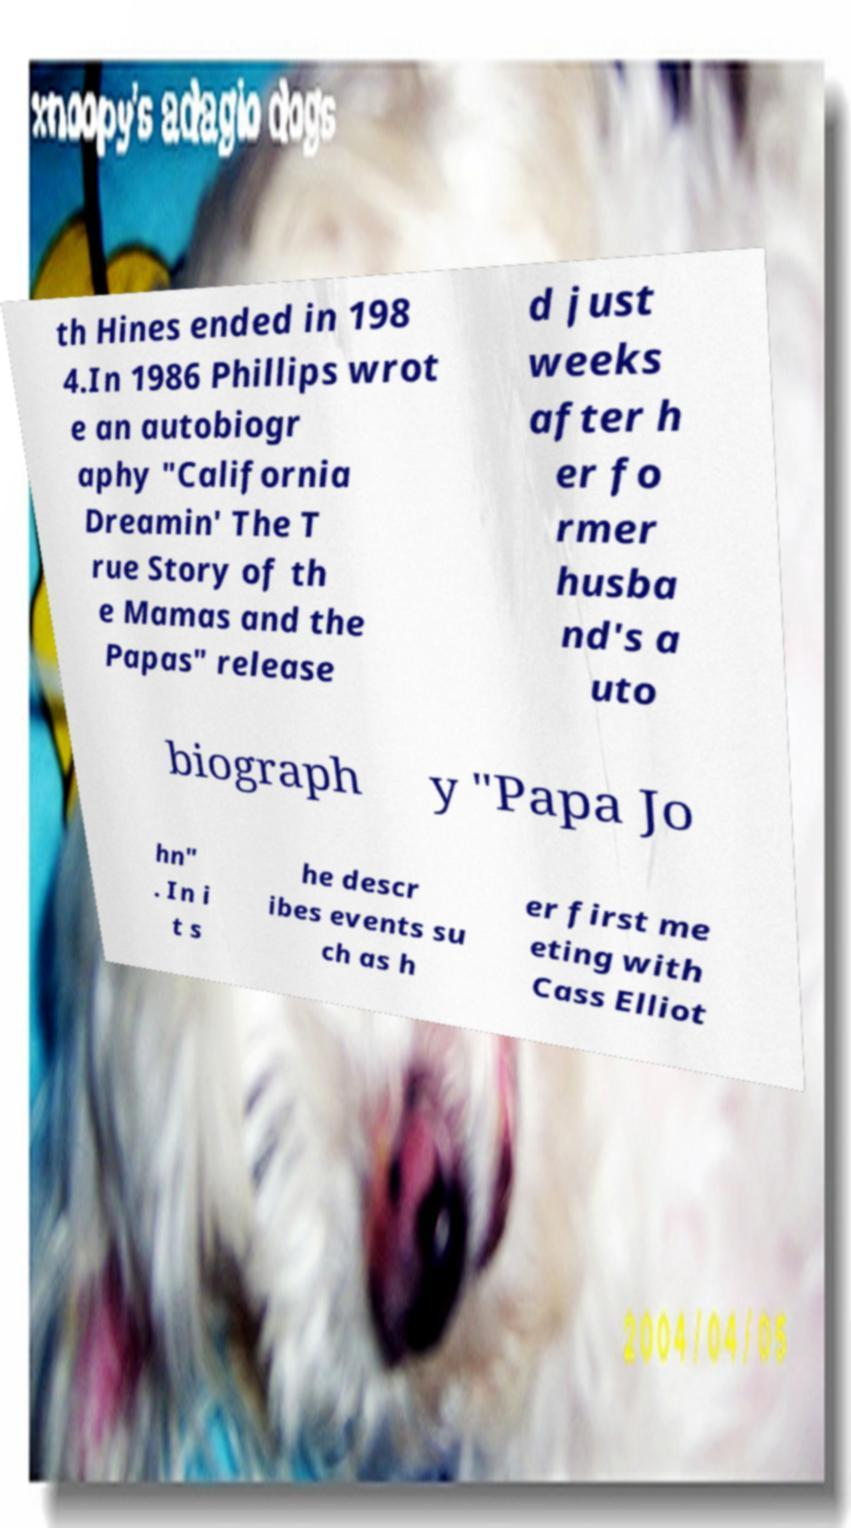For documentation purposes, I need the text within this image transcribed. Could you provide that? th Hines ended in 198 4.In 1986 Phillips wrot e an autobiogr aphy "California Dreamin' The T rue Story of th e Mamas and the Papas" release d just weeks after h er fo rmer husba nd's a uto biograph y "Papa Jo hn" . In i t s he descr ibes events su ch as h er first me eting with Cass Elliot 